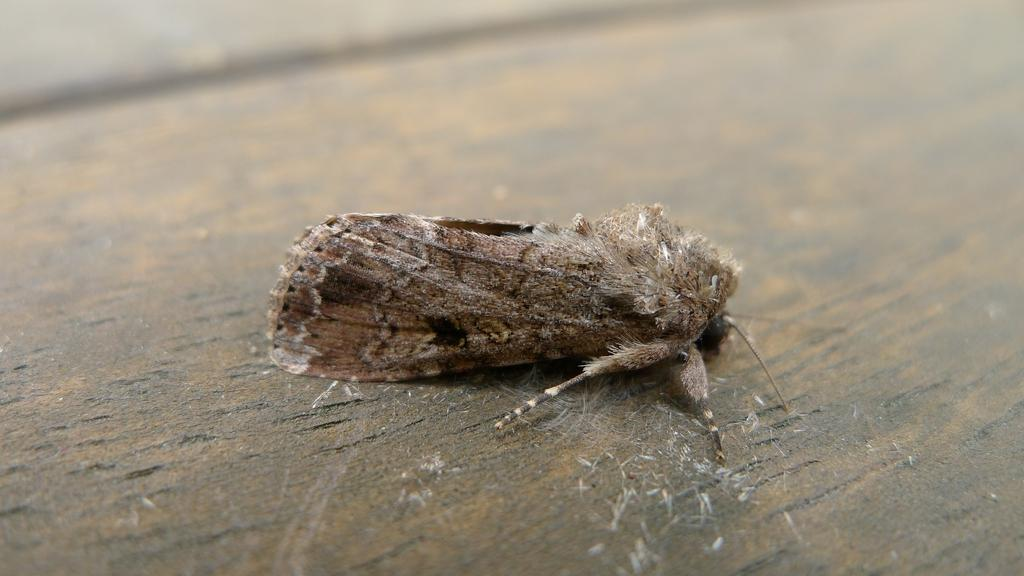What type of creature can be seen in the image? There is an insect in the image. What surface is the insect located on? The insect is on a wooden surface. What type of aunt can be seen in the image? There is no aunt present in the image; it features an insect on a wooden surface. What is the quarter of the image that shows the insect? The concept of "quarters" does not apply to this image, as it is a two-dimensional representation. 